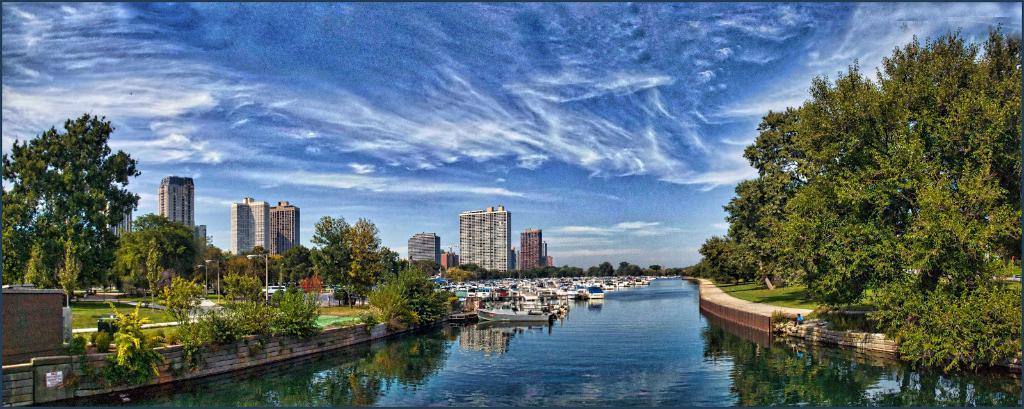What is on the water in the image? There are boats on the water in the image. What type of vegetation can be seen in the image? There are trees visible in the image. What type of structures are present in the image? There are buildings in the image. What else can be seen in the image besides the boats, trees, and buildings? There are poles in the image. What is visible in the background of the image? The sky with clouds is visible in the background of the image. Can you tell me how many teeth the person in the image is brushing with toothpaste? There is no person brushing their teeth with toothpaste in the image; it features boats on the water, trees, buildings, poles, and a sky with clouds. 